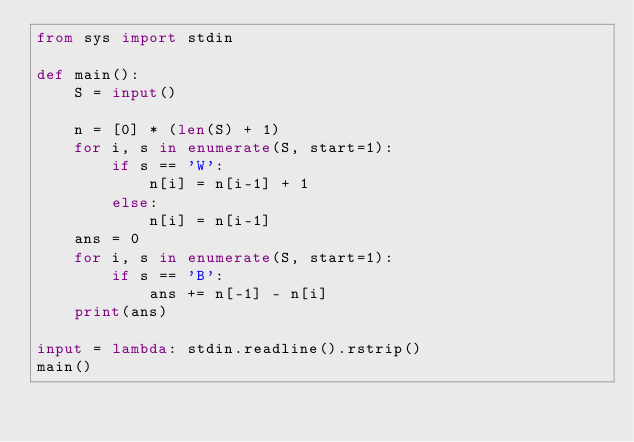<code> <loc_0><loc_0><loc_500><loc_500><_Python_>from sys import stdin

def main():
    S = input()

    n = [0] * (len(S) + 1)
    for i, s in enumerate(S, start=1):
        if s == 'W':
            n[i] = n[i-1] + 1
        else:
            n[i] = n[i-1]
    ans = 0
    for i, s in enumerate(S, start=1):
        if s == 'B':
            ans += n[-1] - n[i]
    print(ans)

input = lambda: stdin.readline().rstrip()
main()
</code> 